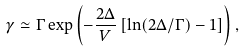Convert formula to latex. <formula><loc_0><loc_0><loc_500><loc_500>\gamma \simeq \Gamma \exp \left ( - \frac { 2 \Delta } { V } \left [ \ln ( 2 \Delta / \Gamma ) - 1 \right ] \right ) ,</formula> 